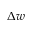<formula> <loc_0><loc_0><loc_500><loc_500>\Delta w</formula> 